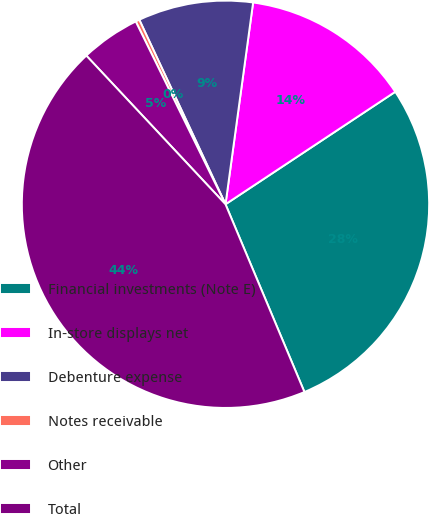Convert chart. <chart><loc_0><loc_0><loc_500><loc_500><pie_chart><fcel>Financial investments (Note E)<fcel>In-store displays net<fcel>Debenture expense<fcel>Notes receivable<fcel>Other<fcel>Total<nl><fcel>27.98%<fcel>13.52%<fcel>9.12%<fcel>0.31%<fcel>4.71%<fcel>44.36%<nl></chart> 